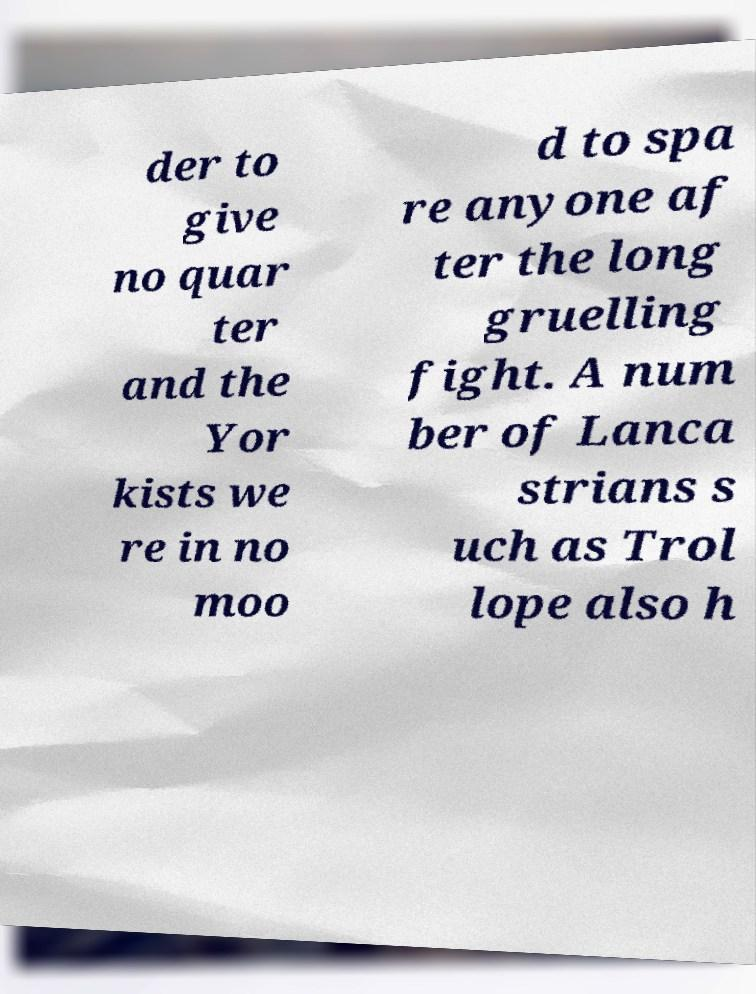For documentation purposes, I need the text within this image transcribed. Could you provide that? der to give no quar ter and the Yor kists we re in no moo d to spa re anyone af ter the long gruelling fight. A num ber of Lanca strians s uch as Trol lope also h 